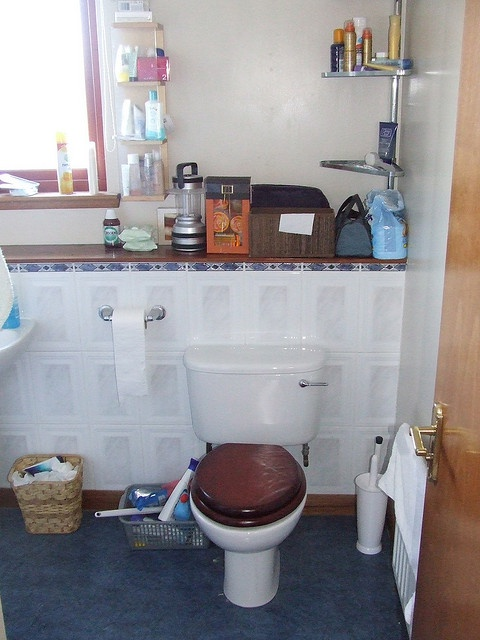Describe the objects in this image and their specific colors. I can see toilet in white, darkgray, maroon, and black tones, sink in white, lightgray, darkgray, and lightblue tones, handbag in white, black, and blue tones, bottle in white, darkgray, gray, and blue tones, and bottle in white, darkgray, gray, and lightgray tones in this image. 